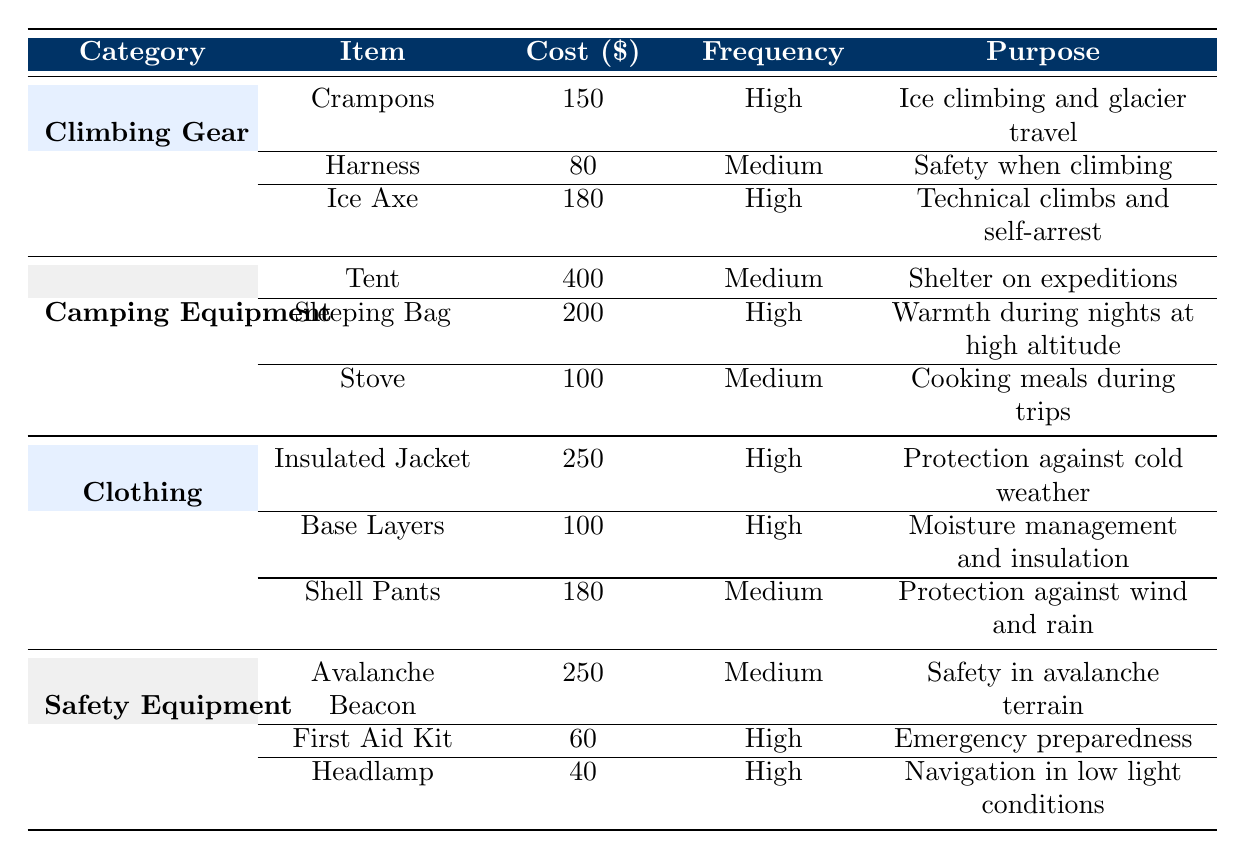What is the cost of the Sleeping Bag? The Sleeping Bag is listed in the Camping Equipment category, and its Cost is explicitly mentioned as 200.
Answer: 200 Which item has the highest frequency of use? By looking at the Frequency column, the items with "High" frequency are Crampons, Ice Axe, Sleeping Bag, Insulated Jacket, Base Layers, First Aid Kit, and Headlamp. Since there are multiple items, any of those can be considered as highest frequency items.
Answer: Crampons, Ice Axe, Sleeping Bag, Insulated Jacket, Base Layers, First Aid Kit, Headlamp How much does the average Climbing Gear cost? The Climbing Gear category contains three items: Crampons (150), Harness (80), and Ice Axe (180). The total cost is 150 + 80 + 180 = 410. The average cost is calculated as 410 / 3 = 136.67.
Answer: 136.67 Is the cost of the Tent higher than the average cost of Safety Equipment? The Tent costs 400, and in the Safety Equipment category, the costs are the Avalanche Beacon (250), First Aid Kit (60), and Headlamp (40). The average cost for Safety Equipment is (250 + 60 + 40) / 3 = 116.67. Since 400 > 116.67, the Tent’s cost is higher.
Answer: Yes What is the total cost of all items with High frequency of use? The items with High frequency of use are Crampons (150), Ice Axe (180), Sleeping Bag (200), Insulated Jacket (250), Base Layers (100), First Aid Kit (60), and Headlamp (40). Adding these together gives: 150 + 180 + 200 + 250 + 100 + 60 + 40 = 980.
Answer: 980 